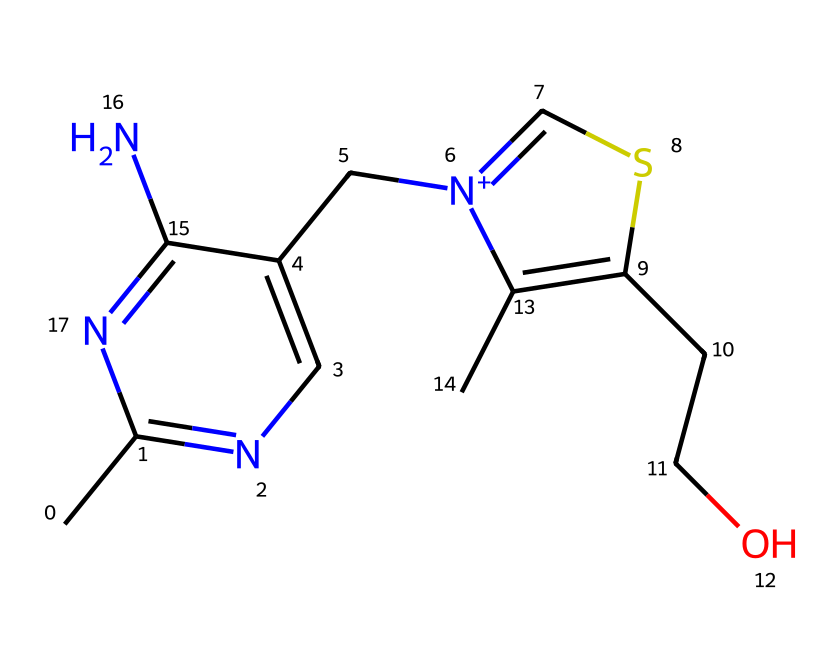What is the total number of nitrogen atoms in this compound? By examining the SMILES representation, we can identify nitrogen atoms (N) directly. There are three instances of the nitrogen atom present in the structure.
Answer: three What is the primary function of this vitamin B complex compound? This compound is involved in energy metabolism, which is essential for athletes to convert food into energy effectively.
Answer: energy metabolism How many carbon atoms are indicated in the molecular structure? By counting the carbon atoms (C) in the SMILES notation, we find that there are eight carbon atoms in total.
Answer: eight What type of medicinal compound is represented by this structure? Given the presence of multiple nitrogen and sulfur atoms along with a complex aromatic structure, this compound is identified as a vitamin, specifically related to the B complex group.
Answer: vitamin Does this structure contain any functional groups? The molecular structure includes an amine group (indicated by the presence of nitrogen atoms), which contributes to the compound's biological activity related to metabolism.
Answer: amine What is the presence of sulfur in the chemical structure? The SMILES representation shows one sulfur atom, which may play a role in biochemical functions, particularly in enzymatic processes relevant to energy metabolism.
Answer: one How many distinct ring structures are present in this compound? The SMILES shows two ring structures: one is a pyrimidine ring due to its nitrogen content and the other is a thiophene-like structure. Thus, there are two distinct rings visible.
Answer: two 